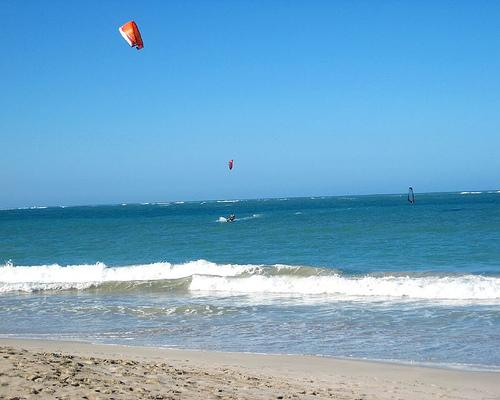To what is this sail attached?

Choices:
A) nothing
B) shark
C) beach comber
D) surfer surfer 